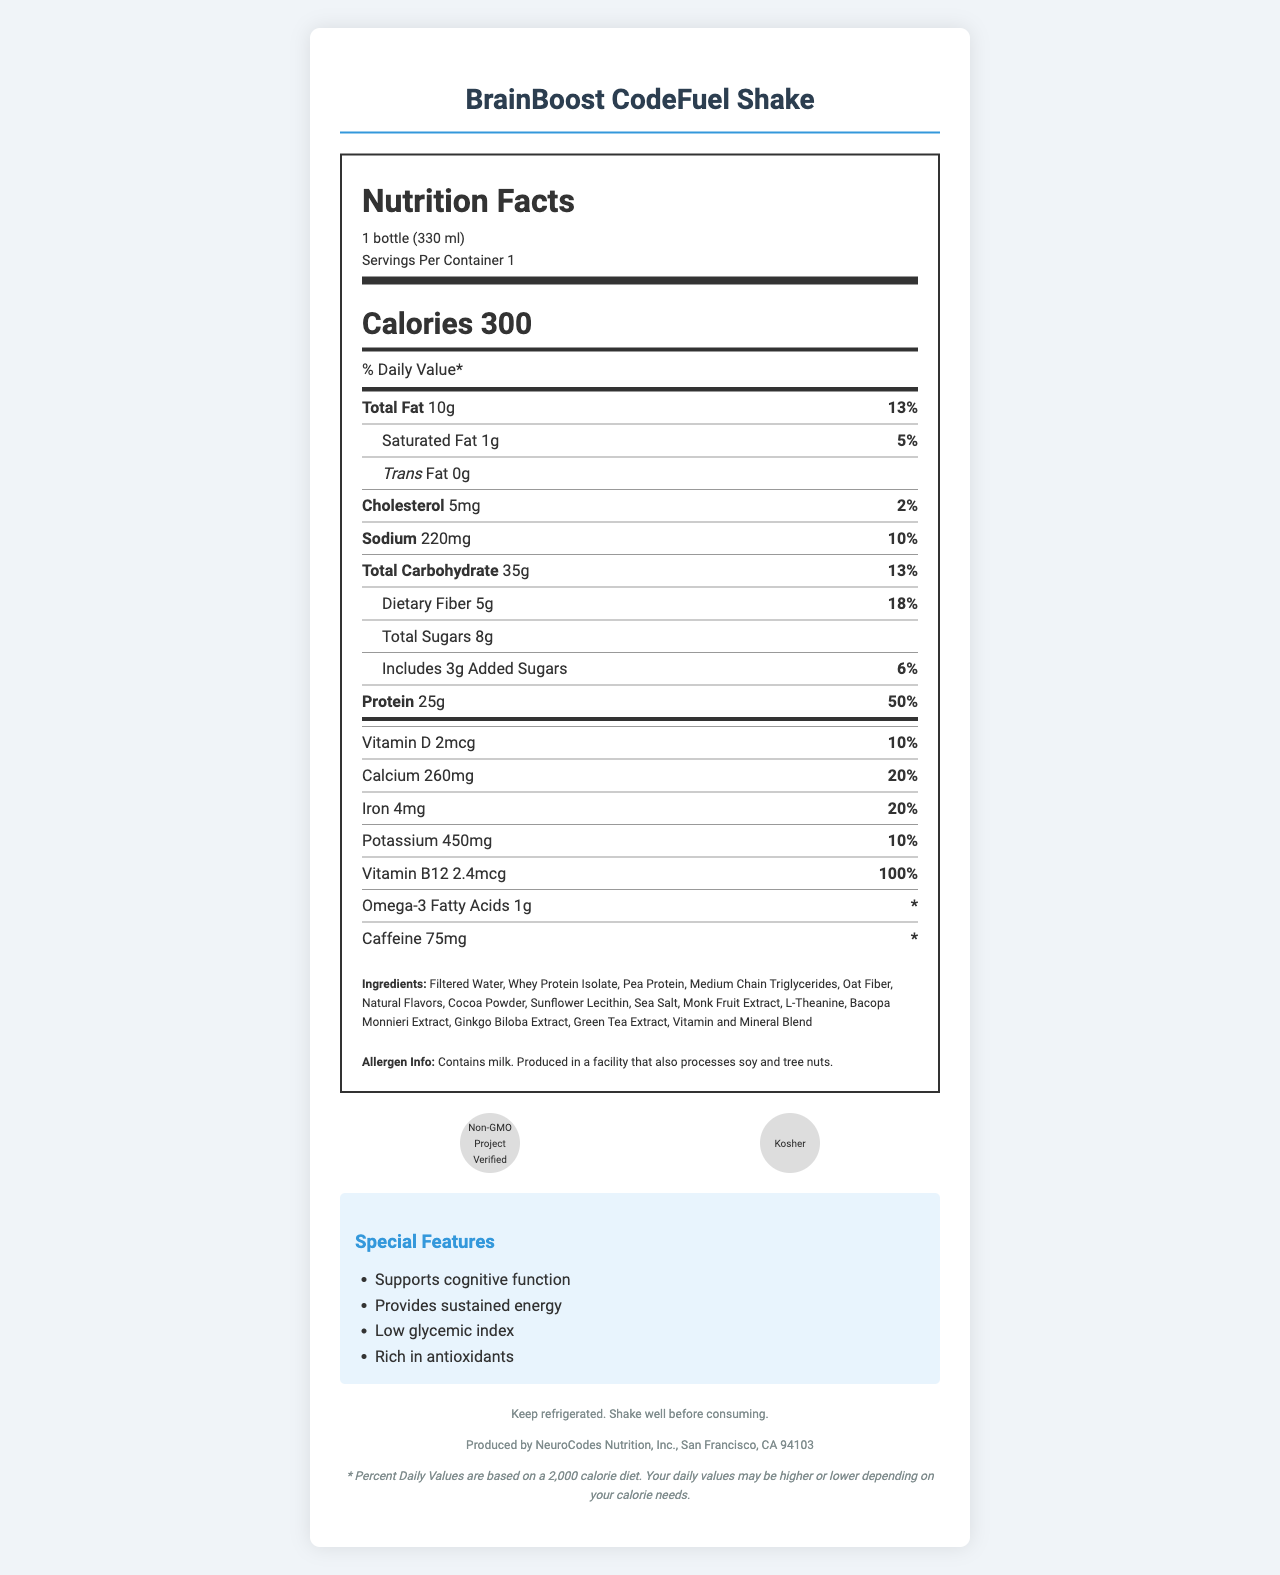how many calories are in one serving? The document states that each serving of the BrainBoost CodeFuel Shake contains 300 calories.
Answer: 300 what is the serving size for the BrainBoost CodeFuel Shake? The serving size is provided as "1 bottle (330 ml)" in the document.
Answer: 1 bottle (330 ml) how much total fat is in one serving? The total fat per serving is listed as 10 grams.
Answer: 10g what percentage of the daily value for protein does one serving provide? One serving contains 25g of protein, which is 50% of the daily value.
Answer: 50% what minerals and vitamins are included in the BrainBoost CodeFuel Shake? The list of vitamins and minerals includes Vitamin D, Calcium, Iron, Potassium, Vitamin B12, Omega-3 Fatty Acids, and Caffeine.
Answer: Vitamin D, Calcium, Iron, Potassium, Vitamin B12, Omega-3 Fatty Acids, Caffeine what special features does the BrainBoost CodeFuel Shake have? A. Supports cognitive function B. Provides sustained energy C. High in sugar D. Rich in antioxidants The special features listed are: Supports cognitive function, Provides sustained energy, Low glycemic index, and Rich in antioxidants. It is not high in sugar.
Answer: C what is the allergen information mentioned? A. Contains soy B. Contains dairy C. Contains gluten D. Contains egg The document states that the product contains milk and is produced in a facility that processes soy and tree nuts.
Answer: B is the BrainBoost CodeFuel Shake certified Non-GMO? One of the certifications listed is "Non-GMO Project Verified."
Answer: Yes describe the main purpose of the BrainBoost CodeFuel Shake. The shake is tailored to support cognitive function and sustained energy, ideal for software engineers during coding sessions, as indicated by the special features and ingredients.
Answer: To provide a balanced meal replacement shake that supports cognitive function and sustained energy, especially beneficial for coding sessions. does the BrainBoost CodeFuel Shake contain any artificial flavors? The document states that the shake contains "Natural Flavors," but does not provide explicit information about the inclusion or exclusion of artificial flavors.
Answer: Not enough information/Not specified 